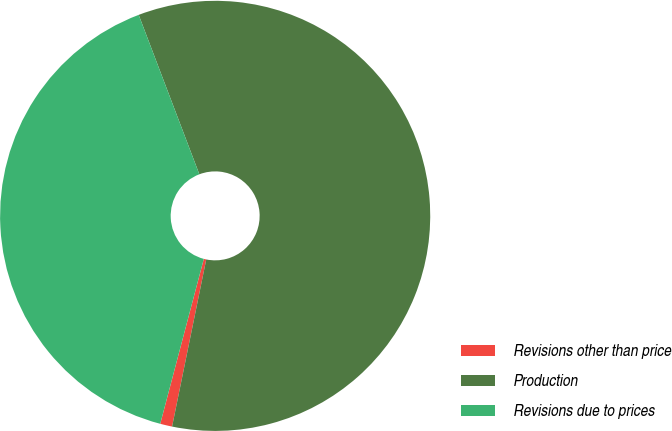Convert chart. <chart><loc_0><loc_0><loc_500><loc_500><pie_chart><fcel>Revisions other than price<fcel>Production<fcel>Revisions due to prices<nl><fcel>0.9%<fcel>58.99%<fcel>40.1%<nl></chart> 